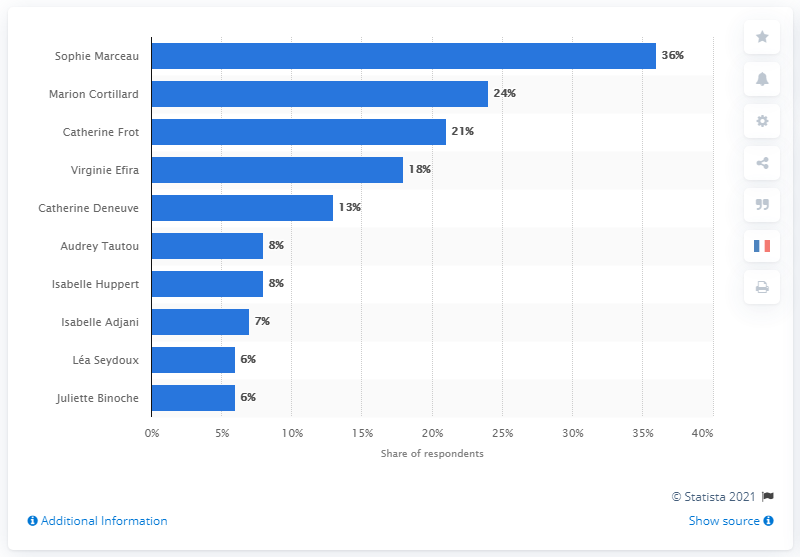Outline some significant characteristics in this image. The most popular French actress in 2019 is Sophie Marceau, as declared by public opinion. 